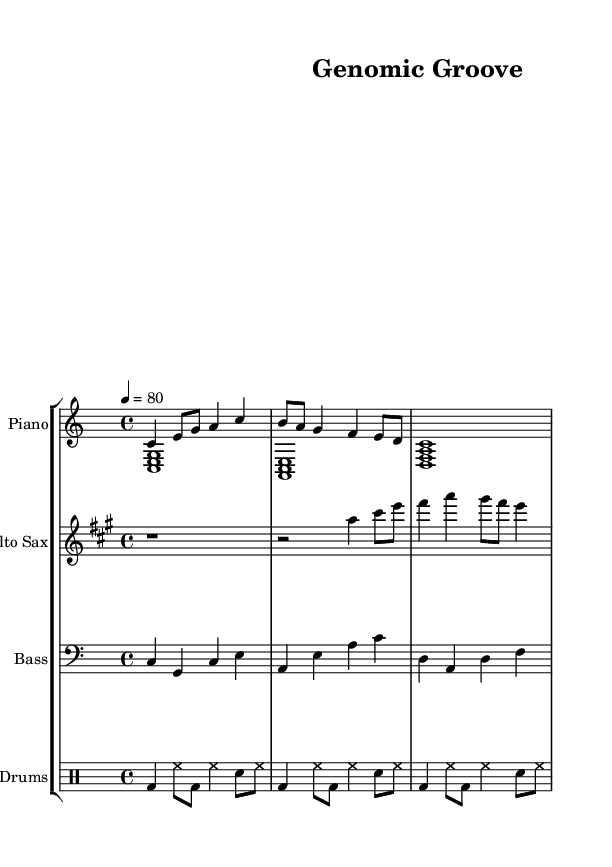What is the key signature of this music? The key signature indicates there are no sharps or flats. This is characteristic of C major.
Answer: C major What is the time signature of this piece? The time signature is shown as 4 over 4, indicating four beats per measure.
Answer: 4/4 What is the tempo marking for this composition? The tempo marking specifies 80 beats per minute, indicated by the "4 = 80" notation.
Answer: 80 How many measures are there in the drum pattern? By counting the drum symbols within the provided rhythmic section, there are 12 beats organized in 3 measures of 4/4 each (2 beats per line, 4 lines total).
Answer: 3 What is the main instrument featured in the first staff? The first staff represents the piano, noted by the label "Piano."
Answer: Piano How does the saxophone part start in terms of rest? The saxophone begins with a whole rest, indicated by the "r1" notation at the start of its staff.
Answer: Whole rest What is the rhythmic value of the first note played by the saxophone? The first note played by saxophone after the rest is a quarter note, indicated by the "c4" following the rest.
Answer: Quarter note 